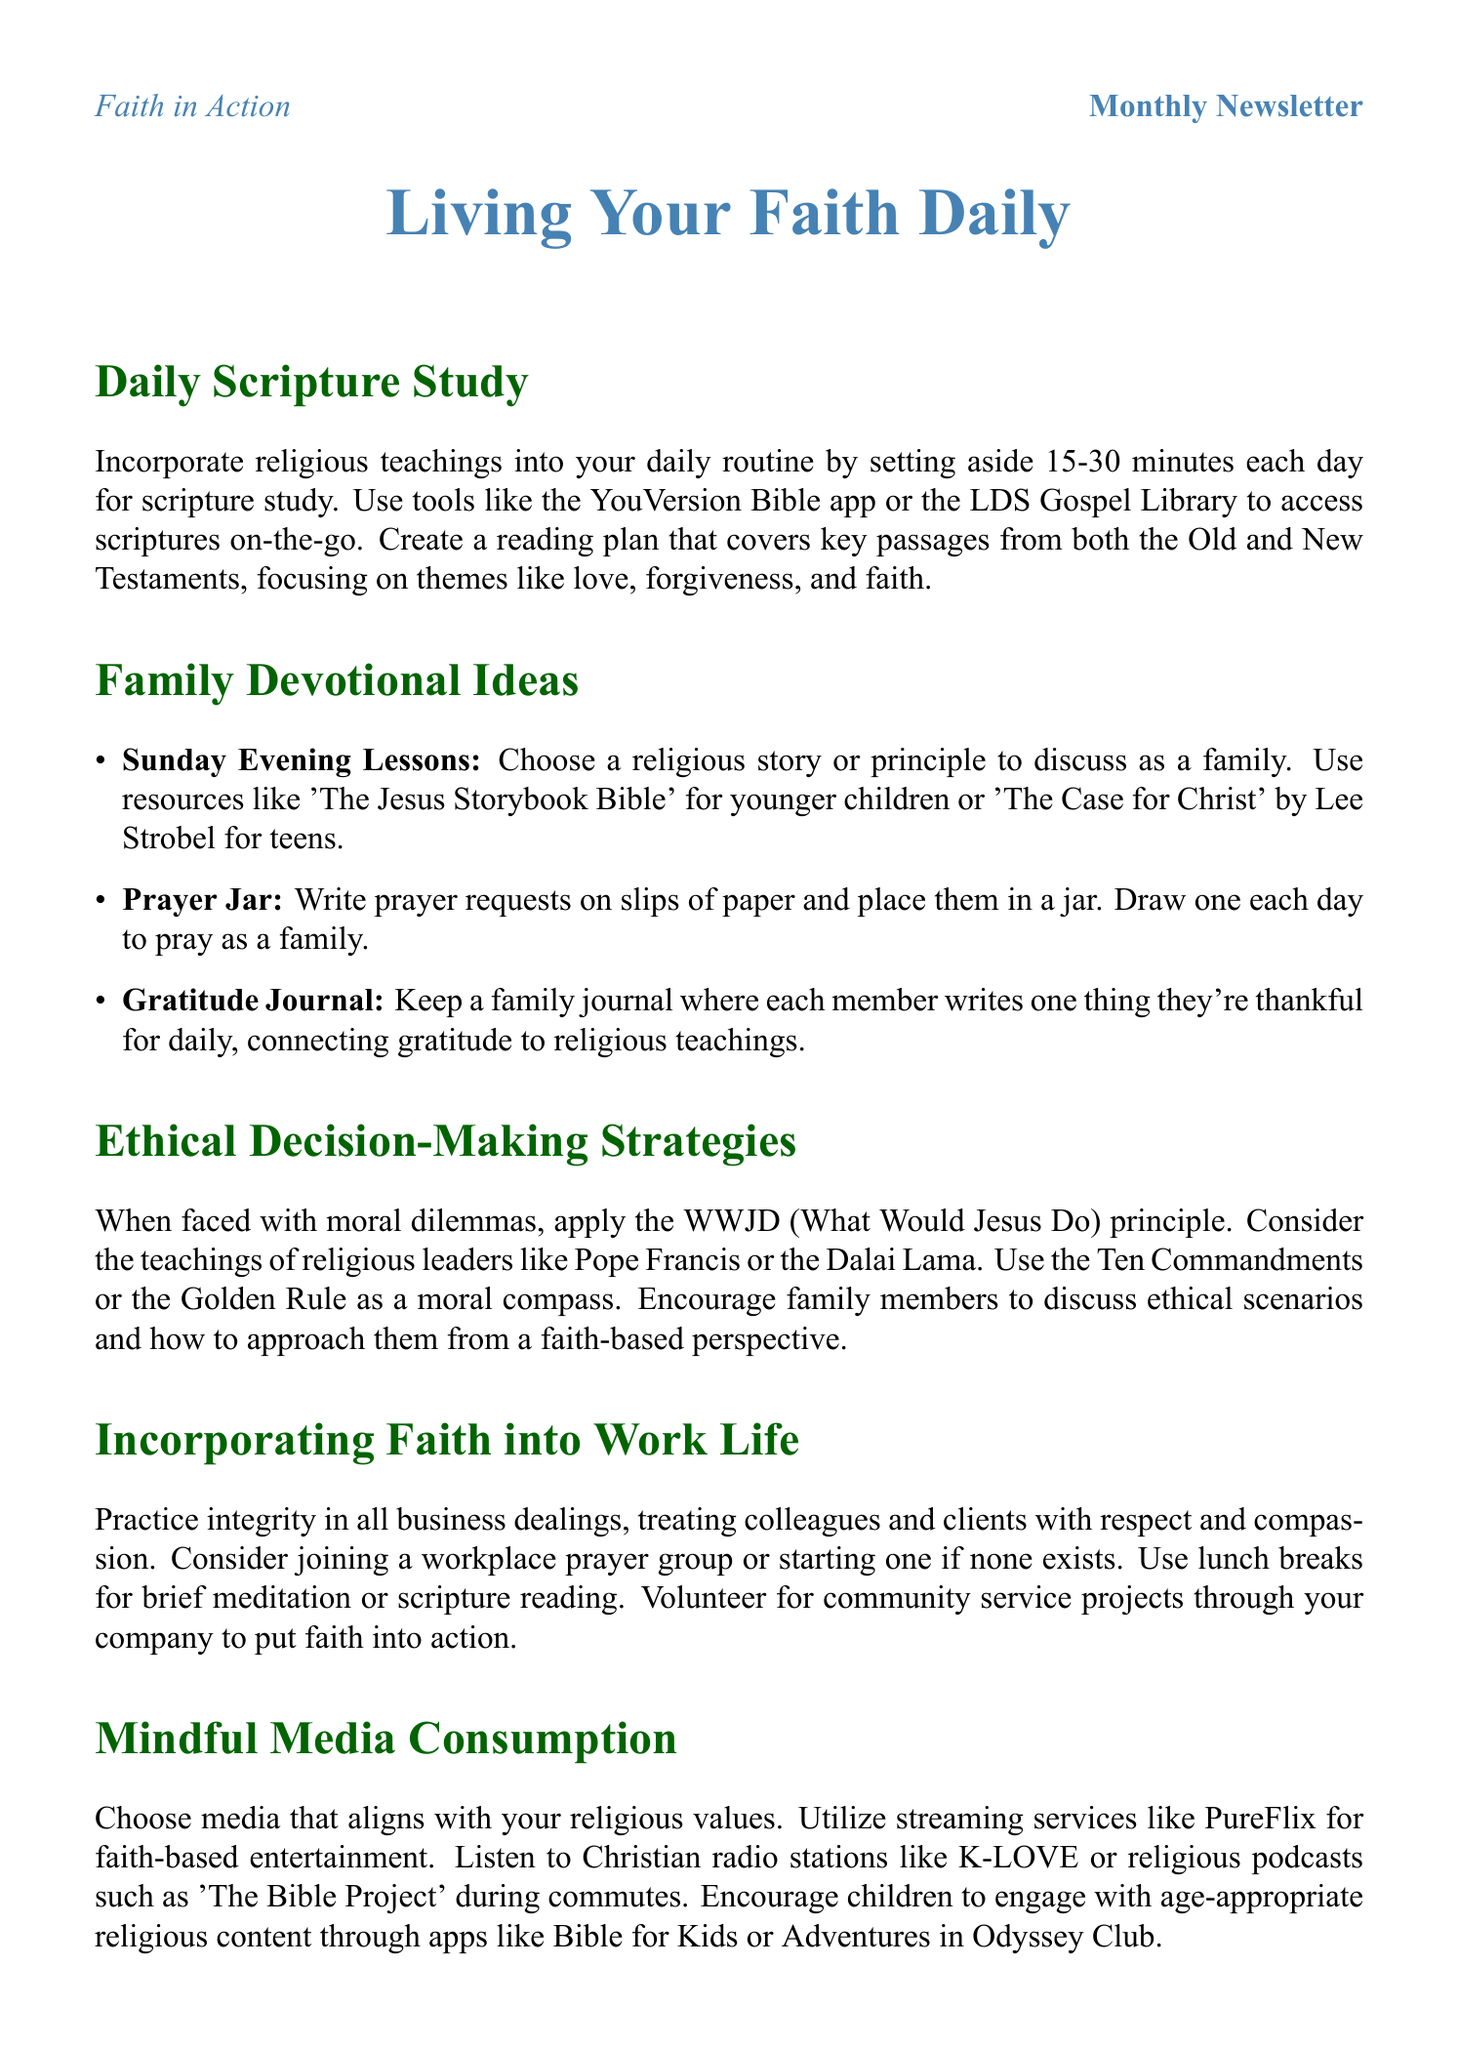What is the suggested daily time for scripture study? The document recommends setting aside 15-30 minutes each day for scripture study.
Answer: 15-30 minutes What resource is recommended for children's religious stories? The document suggests using 'The Jesus Storybook Bible' for younger children.
Answer: The Jesus Storybook Bible What ethical principle is mentioned for making decisions? The newsletter references the WWJD (What Would Jesus Do) principle for ethical decision-making.
Answer: WWJD What is one way to engage children with religious content? The document suggests using apps like Bible for Kids or Adventures in Odyssey Club for children's engagement.
Answer: Bible for Kids How many family devotional ideas are listed? The document includes three specific family devotional ideas in the section.
Answer: Three 